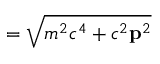Convert formula to latex. <formula><loc_0><loc_0><loc_500><loc_500>= { \sqrt { m ^ { 2 } c ^ { 4 } + c ^ { 2 } p ^ { 2 } } }</formula> 